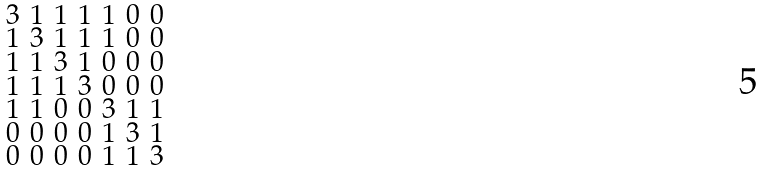<formula> <loc_0><loc_0><loc_500><loc_500>\begin{smallmatrix} 3 & 1 & 1 & 1 & 1 & 0 & 0 \\ 1 & 3 & 1 & 1 & 1 & 0 & 0 \\ 1 & 1 & 3 & 1 & 0 & 0 & 0 \\ 1 & 1 & 1 & 3 & 0 & 0 & 0 \\ 1 & 1 & 0 & 0 & 3 & 1 & 1 \\ 0 & 0 & 0 & 0 & 1 & 3 & 1 \\ 0 & 0 & 0 & 0 & 1 & 1 & 3 \end{smallmatrix}</formula> 